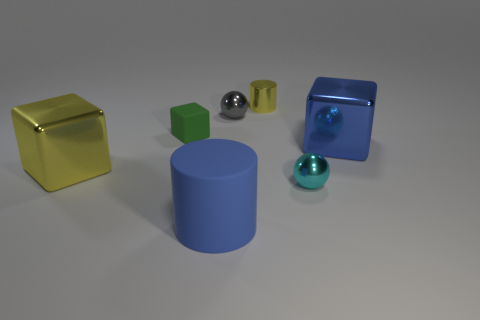Add 1 small cyan shiny things. How many objects exist? 8 Subtract all cubes. How many objects are left? 4 Add 1 red metallic blocks. How many red metallic blocks exist? 1 Subtract 0 red spheres. How many objects are left? 7 Subtract all small matte blocks. Subtract all purple shiny blocks. How many objects are left? 6 Add 2 blue shiny objects. How many blue shiny objects are left? 3 